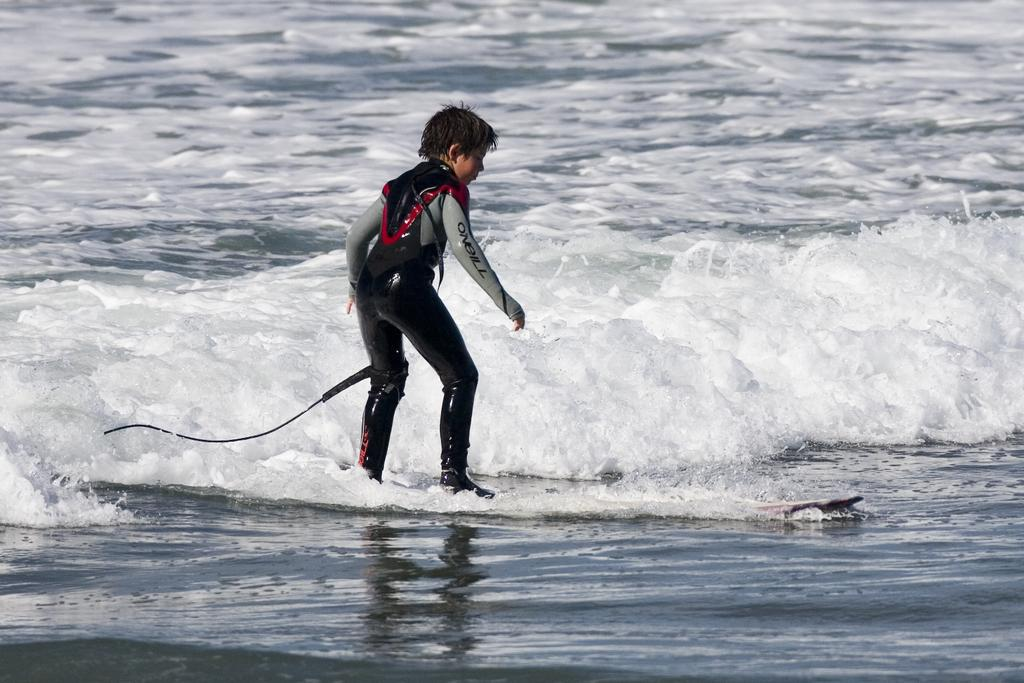<image>
Present a compact description of the photo's key features. A surfer riding a wave wearing a black and grey O-Neill body suit 